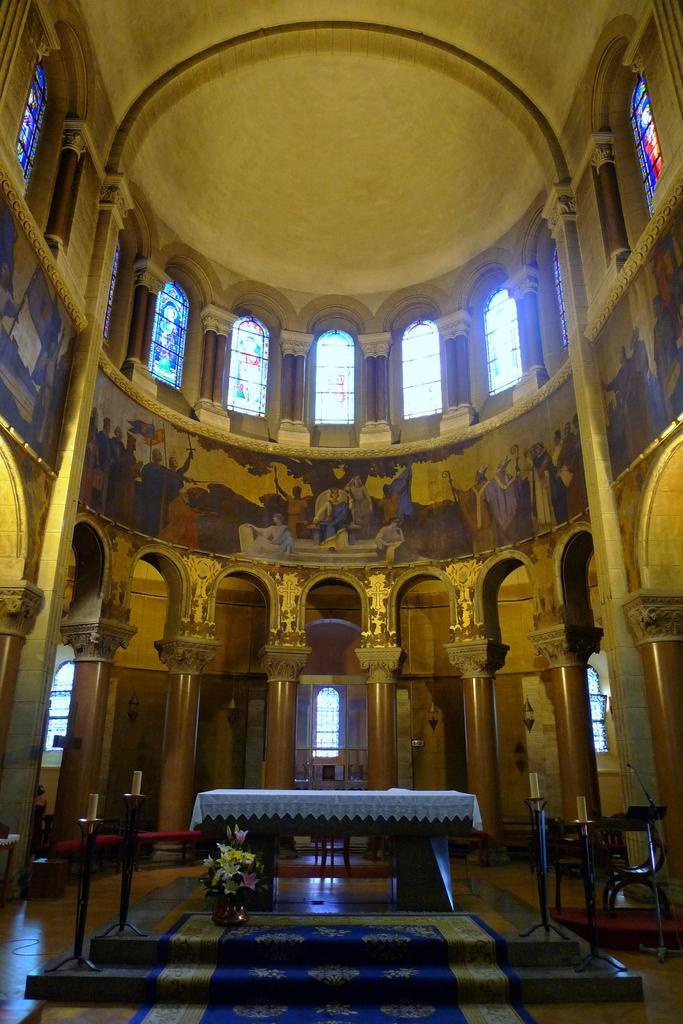Could you give a brief overview of what you see in this image? In this image I can see the inside view of a building. There is a table, carpet and a flower vase. There are pillars, windows, iron stands and there are some other objects. 